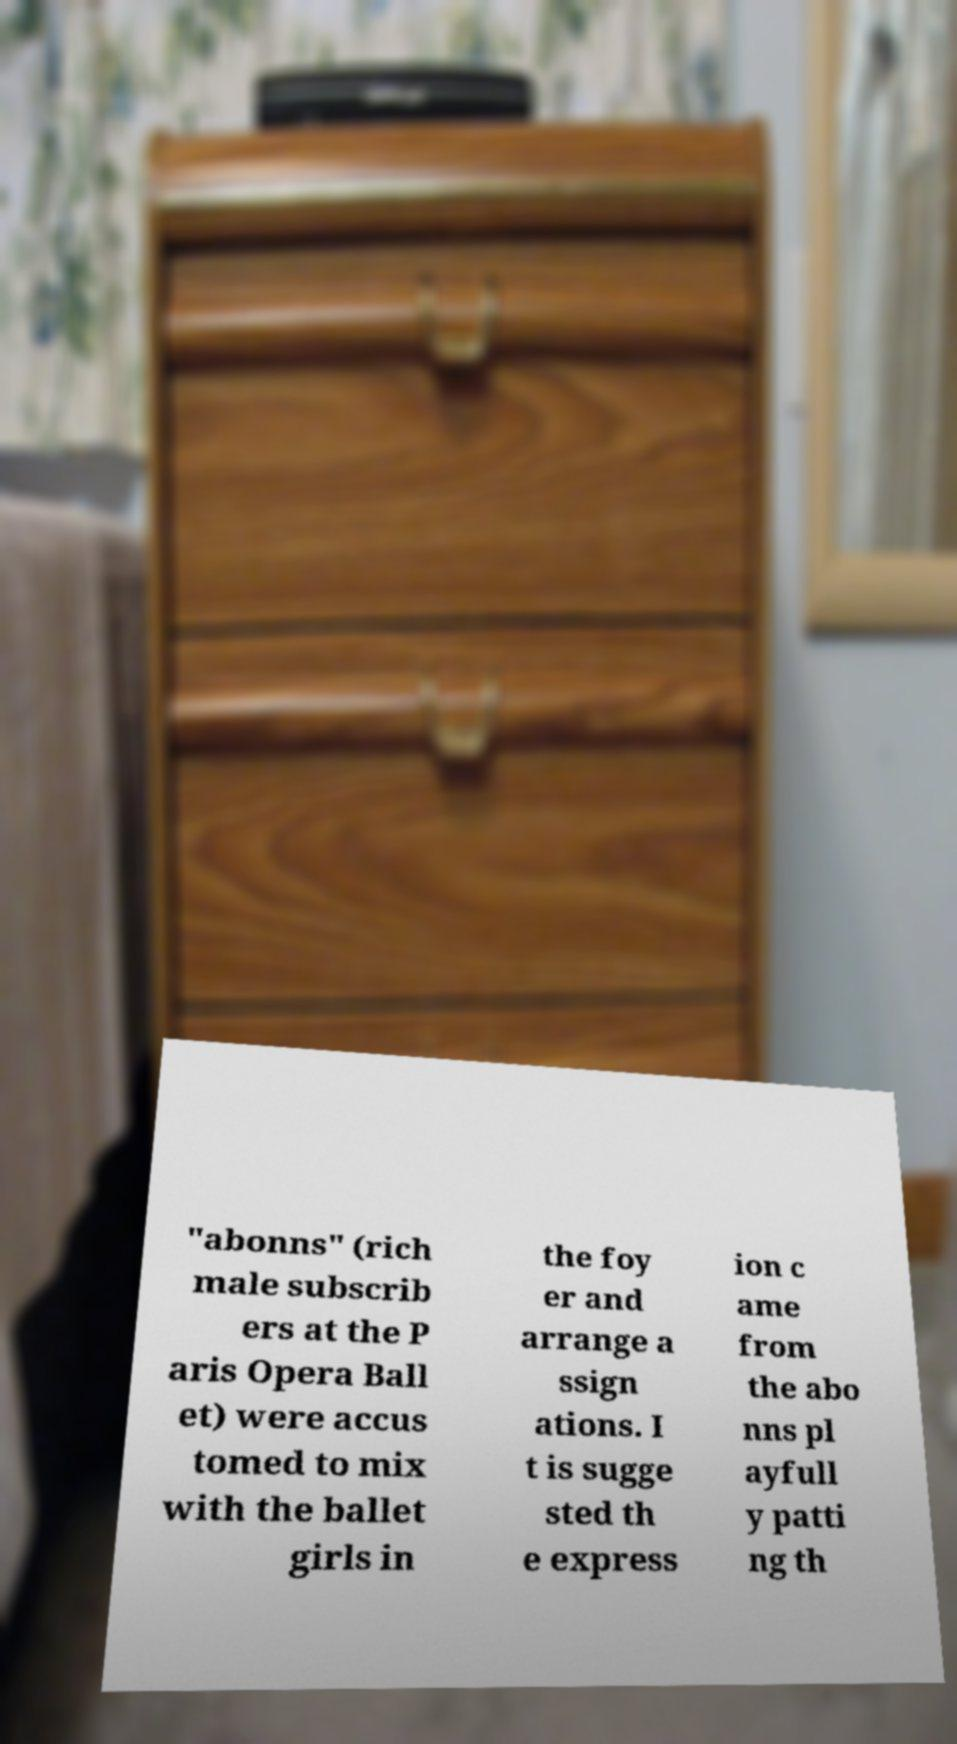There's text embedded in this image that I need extracted. Can you transcribe it verbatim? "abonns" (rich male subscrib ers at the P aris Opera Ball et) were accus tomed to mix with the ballet girls in the foy er and arrange a ssign ations. I t is sugge sted th e express ion c ame from the abo nns pl ayfull y patti ng th 